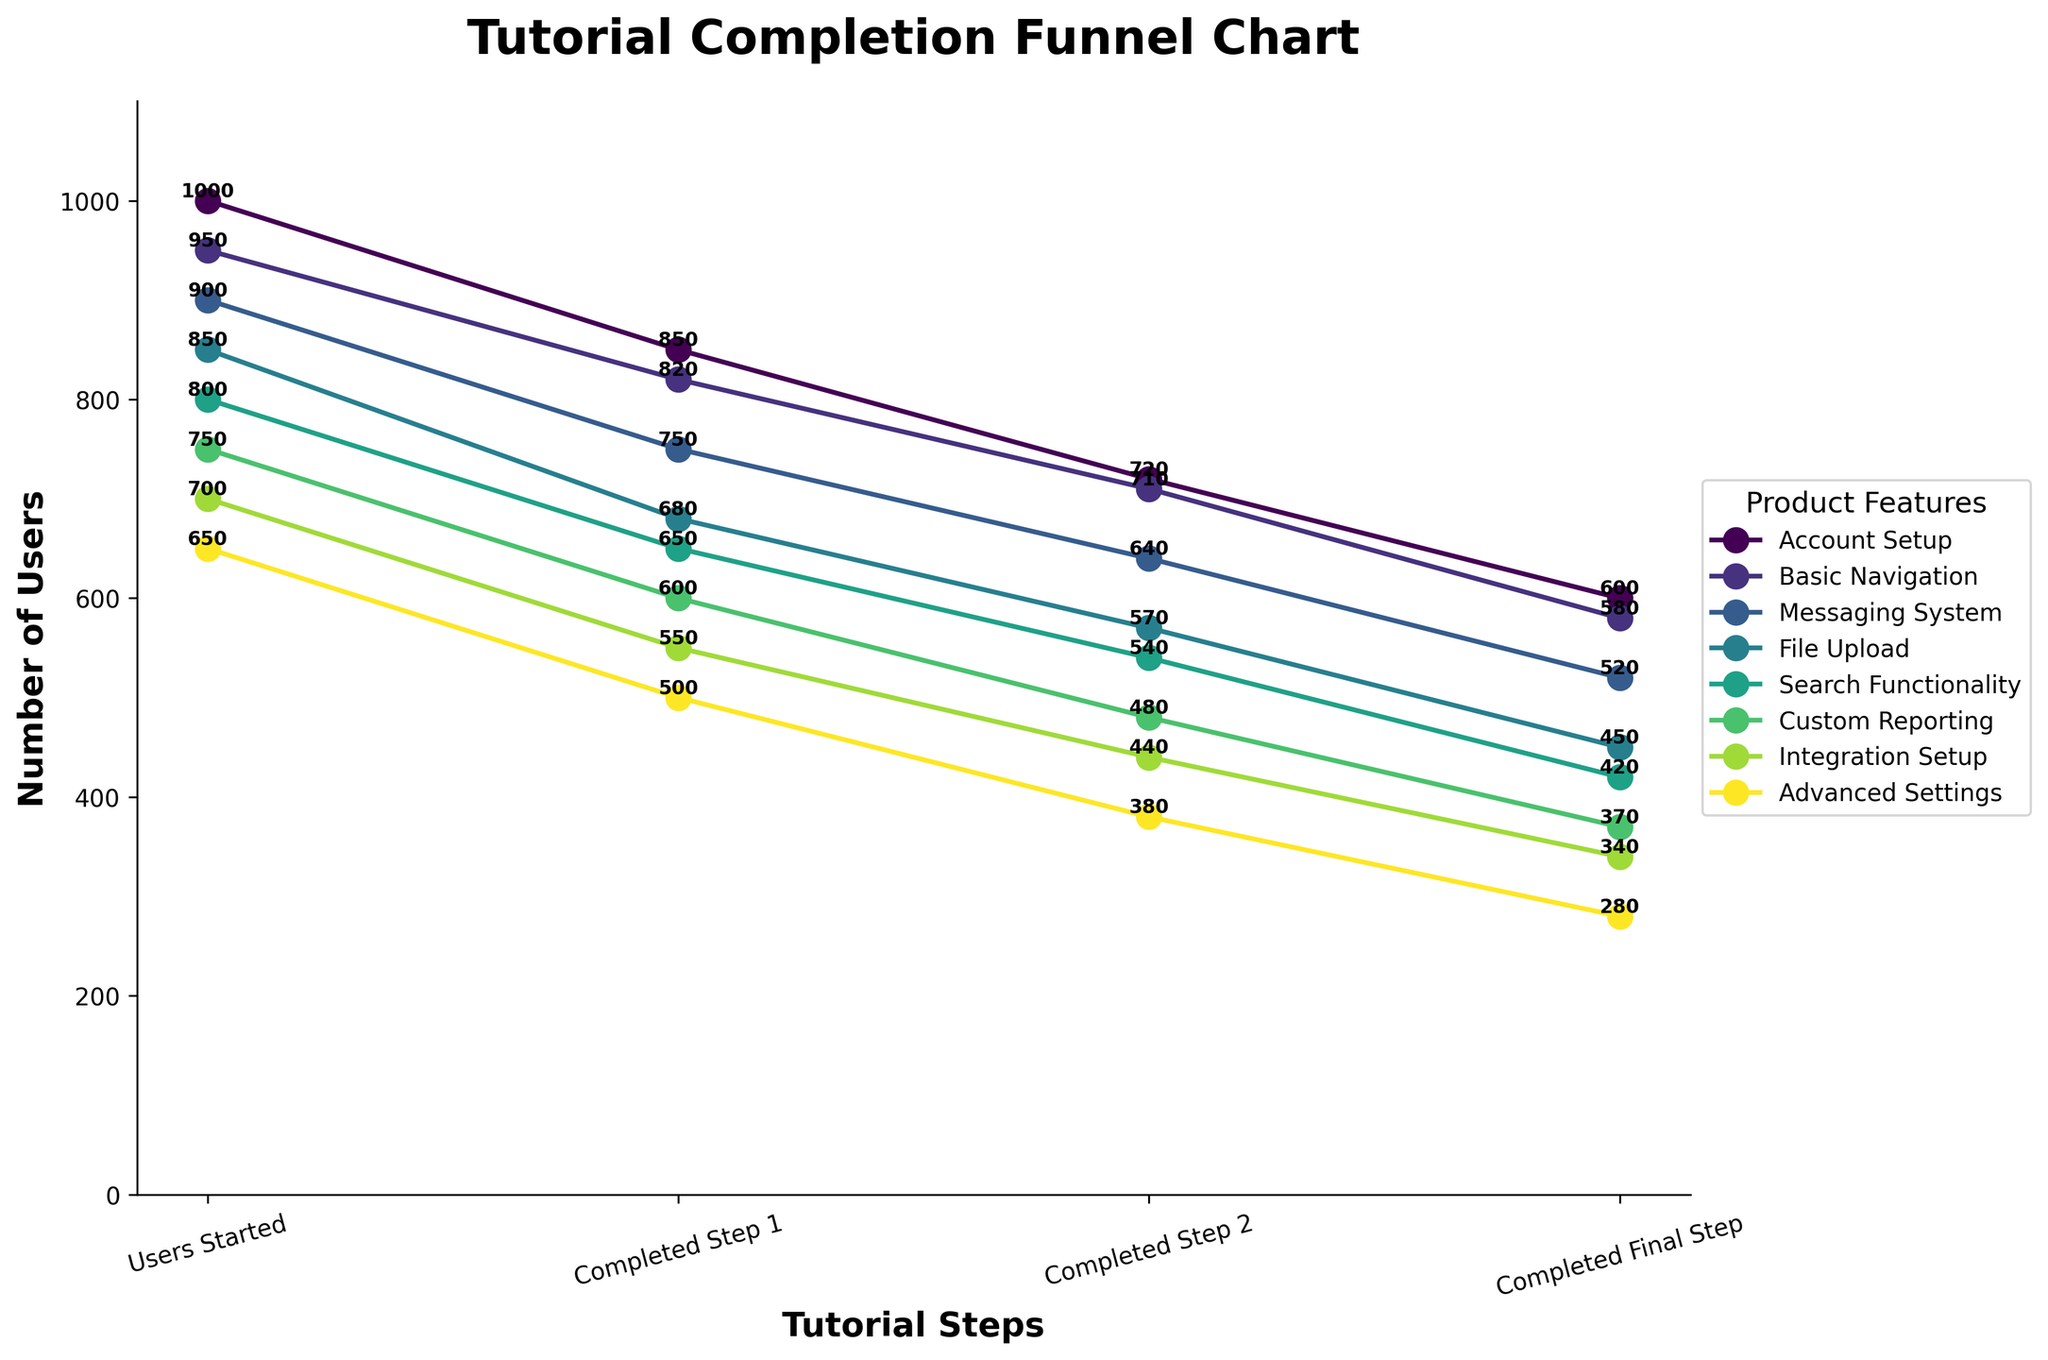What is the title of the chart? The title of the chart is located at the top and it reads 'Tutorial Completion Funnel Chart'.
Answer: Tutorial Completion Funnel Chart How many tutorial steps are represented in the chart? The chart shows four distinct tutorial steps along the horizontal axis. These steps are labeled 'Users Started', 'Completed Step 1', 'Completed Step 2', and 'Completed Final Step'.
Answer: Four Which feature has the highest number of users who started the tutorial? By looking at the first point in each line on the left-most side, the 'Account Setup' feature has the highest number with 1000 users starting the tutorial.
Answer: Account Setup For the 'Search Functionality', how many users completed the final step? The value at the last point of the 'Search Functionality' line shows the number of users who completed the final step. This number is indicated as 420.
Answer: 420 What is the difference between users who started and users who completed the final step for 'Messaging System'? Look at the starting value (900) and the final value (520) for the 'Messaging System' feature. Subtract the final step value from the initial step value: 900 - 520 = 380.
Answer: 380 On average, how many users completed the final step across all features? Calculate the average value by summing the final step values for all features and then dividing by the number of features. The sum is 600 + 580 + 520 + 450 + 420 + 370 + 340 + 280 = 3560. The number of features is 8. So, the average is 3560 / 8 = 445.
Answer: 445 Which feature has the smallest drop in users from 'Completed Step 1' to 'Completed Step 2'? To find the smallest drop, subtract the number of users in 'Completed Step 2' from 'Completed Step 1' for each feature. The smallest difference is 110 for 'Basic Navigation' (820 - 710).
Answer: Basic Navigation Is there a feature where more than 300 users dropped out between 'Users Started' and 'Completed Step 1'? Examine the difference between 'Users Started' and 'Completed Step 1' for each feature. If the difference is more than 300, then it meets the criteria. None of the features show a drop of more than 300 users (closest is 'File Upload' with a drop of 170).
Answer: No Which feature has the steepest decrease in users between any two consecutive steps? By visually examining the lines, one can identify the steepest slope. Specifically, 'Advanced Settings' shows a very steep decrease from 'Completed Step 1' to 'Completed Step 2' (drop from 500 to 380, which is a decrease of 120).
Answer: Advanced Settings 